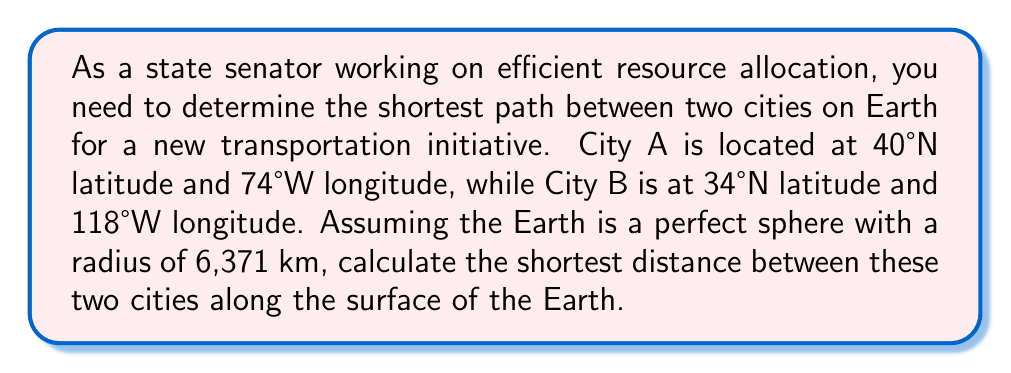Could you help me with this problem? To solve this problem, we'll use the great circle distance formula, which gives the shortest path between two points on a spherical surface. The steps are as follows:

1. Convert the latitudes and longitudes to radians:
   $\phi_1 = 40° \cdot \frac{\pi}{180} = 0.6981$ radians
   $\lambda_1 = -74° \cdot \frac{\pi}{180} = -1.2915$ radians
   $\phi_2 = 34° \cdot \frac{\pi}{180} = 0.5934$ radians
   $\lambda_2 = -118° \cdot \frac{\pi}{180} = -2.0594$ radians

2. Calculate the central angle $\Delta\sigma$ using the Haversine formula:
   $$\Delta\sigma = 2 \arcsin\left(\sqrt{\sin^2\left(\frac{\phi_2 - \phi_1}{2}\right) + \cos\phi_1 \cos\phi_2 \sin^2\left(\frac{\lambda_2 - \lambda_1}{2}\right)}\right)$$

3. Substitute the values:
   $$\Delta\sigma = 2 \arcsin\left(\sqrt{\sin^2\left(\frac{0.5934 - 0.6981}{2}\right) + \cos(0.6981) \cos(0.5934) \sin^2\left(\frac{-2.0594 - (-1.2915)}{2}\right)}\right)$$

4. Calculate the result:
   $\Delta\sigma \approx 0.6505$ radians

5. Multiply by the Earth's radius to get the distance:
   Distance $= R \cdot \Delta\sigma = 6371 \cdot 0.6505 \approx 4143.5$ km

Therefore, the shortest distance between the two cities along the Earth's surface is approximately 4143.5 km.
Answer: 4143.5 km 